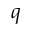<formula> <loc_0><loc_0><loc_500><loc_500>q</formula> 